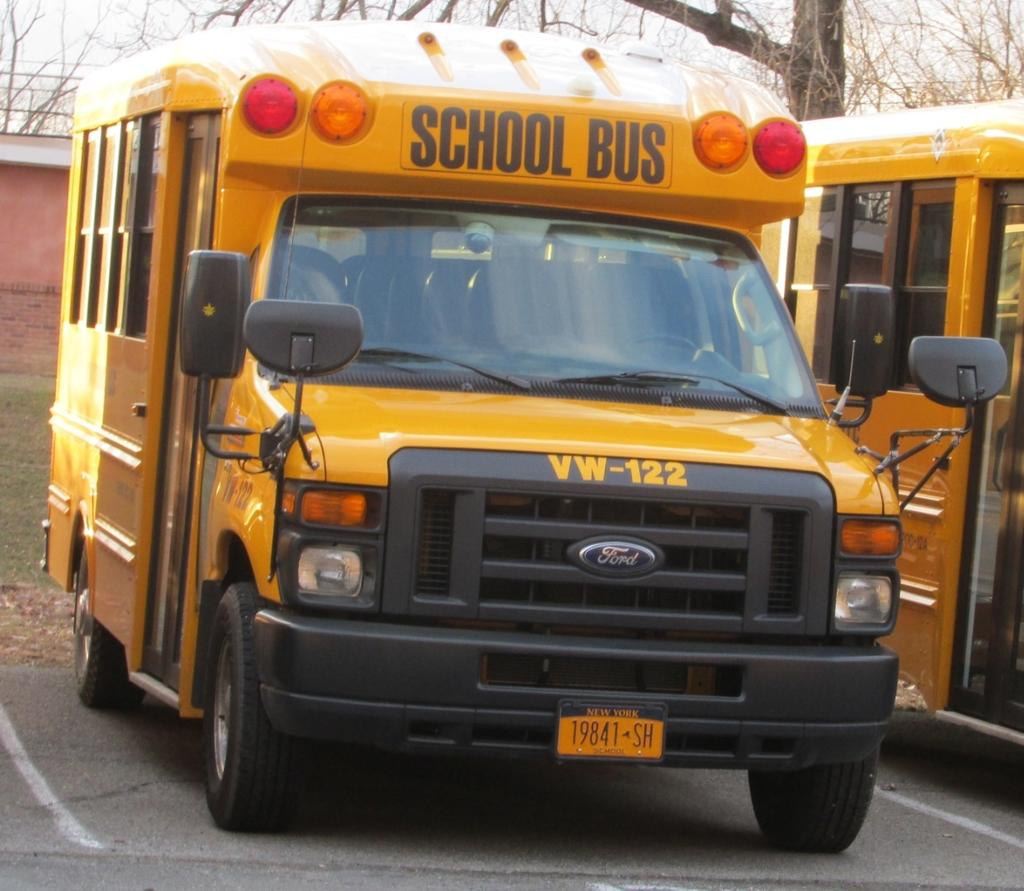<image>
Summarize the visual content of the image. Schoolbus with the license plate "VW-122", parked in a parking lot. 